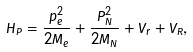<formula> <loc_0><loc_0><loc_500><loc_500>\hat { H } _ { P } = \frac { p _ { e } ^ { 2 } } { 2 M _ { e } } + \frac { \hat { P } _ { N } ^ { 2 } } { 2 M _ { N } } + V _ { r } + V _ { R } ,</formula> 